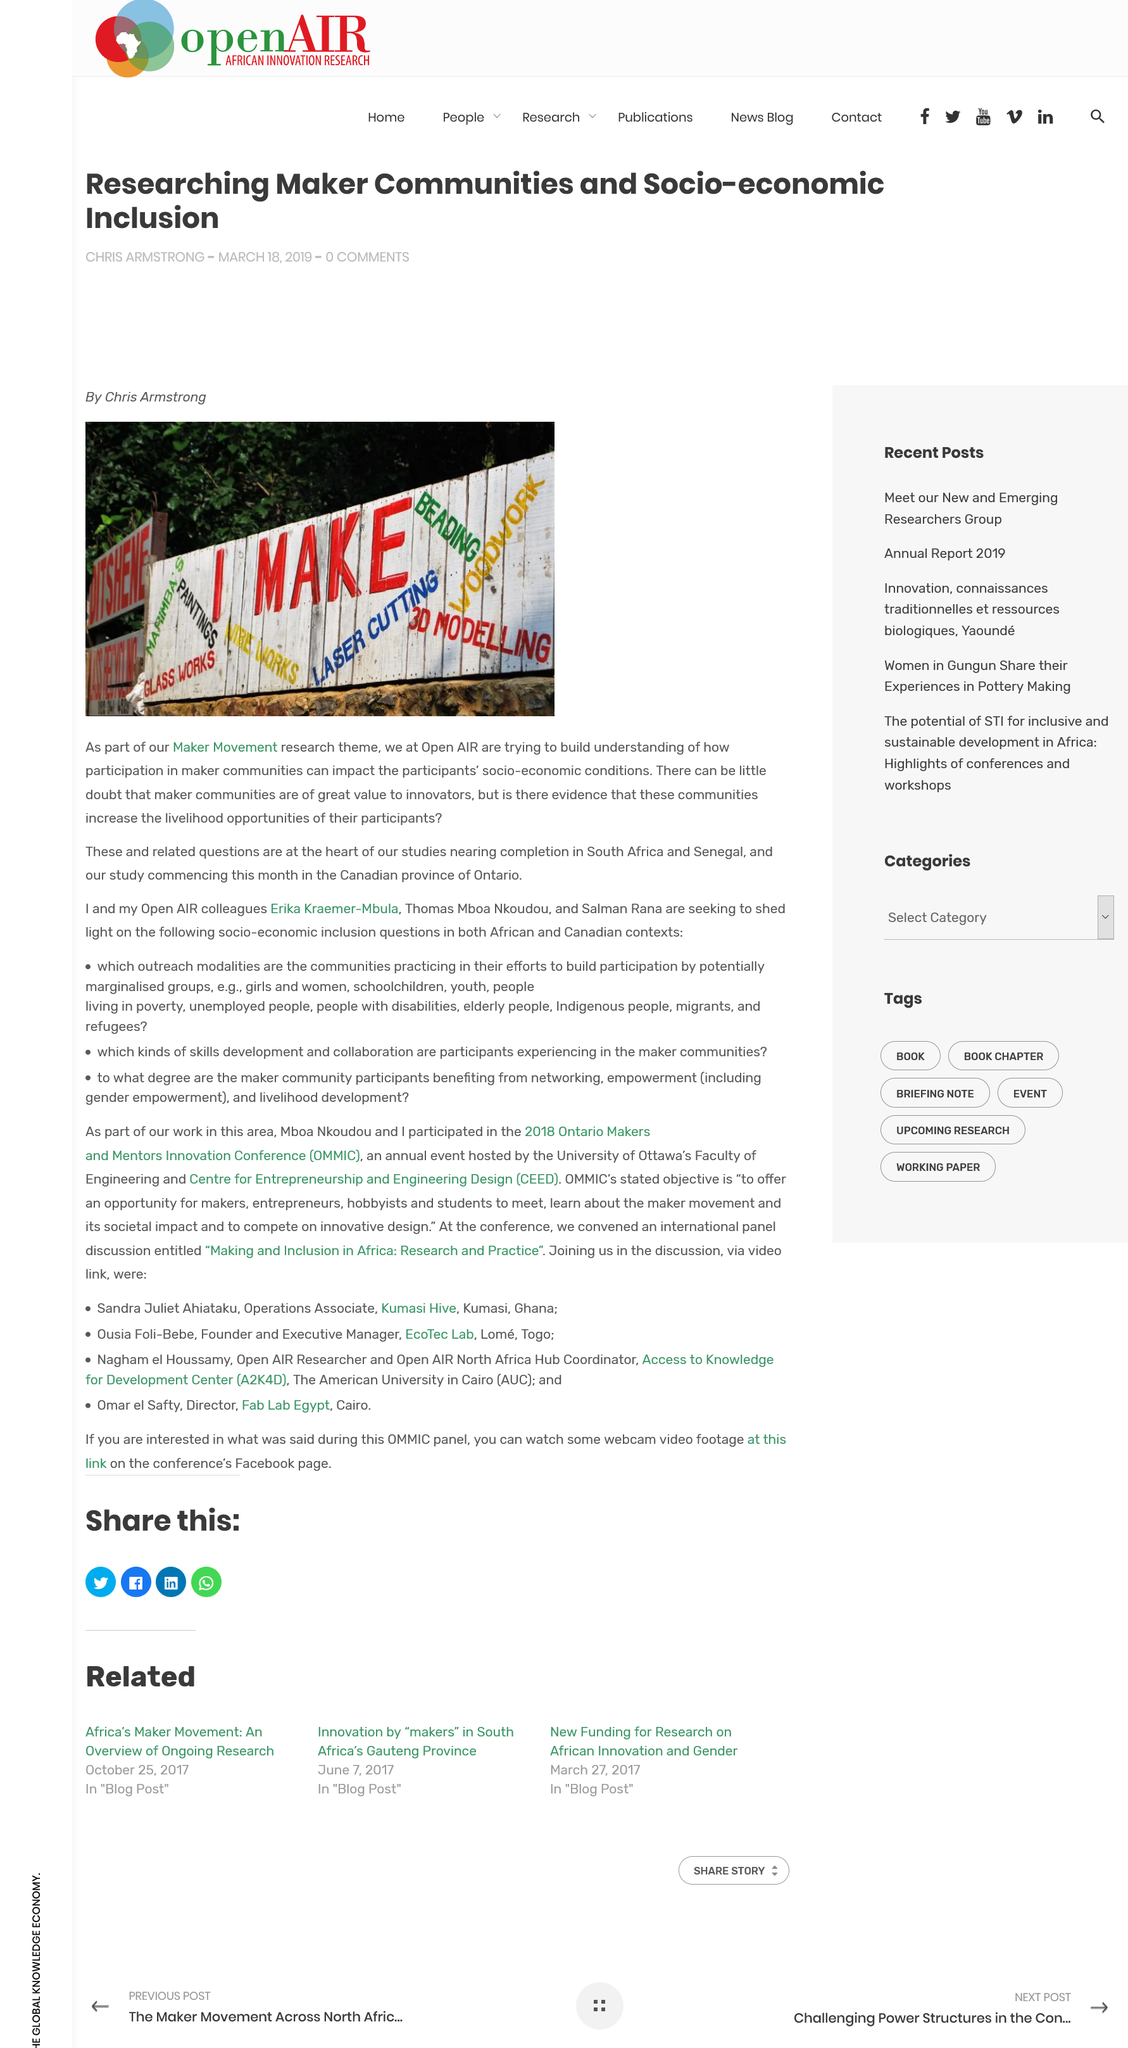Indicate a few pertinent items in this graphic. Open AIR researches the Maker Movement, which is the theme of its studies. Open AIR suggests that the Maker communities created the words on the fence. The largest phrase painted on the fence reads 'I make...' 